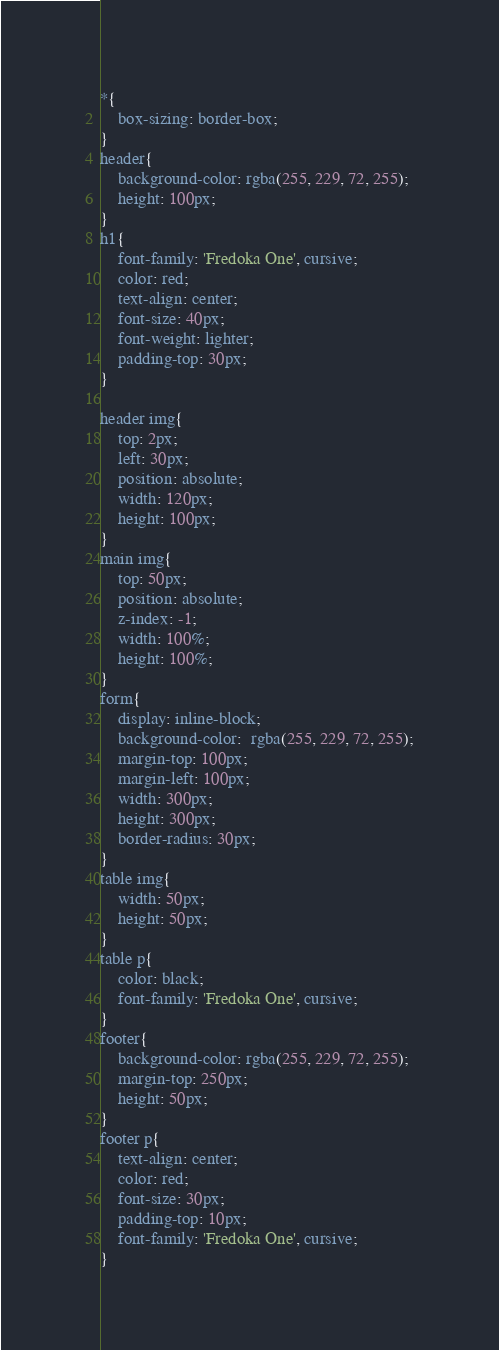Convert code to text. <code><loc_0><loc_0><loc_500><loc_500><_CSS_>*{
    box-sizing: border-box;
}
header{
    background-color: rgba(255, 229, 72, 255);
    height: 100px;
}
h1{
    font-family: 'Fredoka One', cursive;
    color: red;
    text-align: center;
    font-size: 40px;
    font-weight: lighter;
    padding-top: 30px;
}

header img{
    top: 2px;
    left: 30px;
    position: absolute;
    width: 120px;
    height: 100px;
}
main img{
    top: 50px;
    position: absolute;
    z-index: -1;
    width: 100%;
    height: 100%;
}
form{
    display: inline-block;
    background-color:  rgba(255, 229, 72, 255);
    margin-top: 100px;
    margin-left: 100px;
    width: 300px;
    height: 300px;
    border-radius: 30px;
}
table img{
    width: 50px;
    height: 50px;
}
table p{
    color: black;
    font-family: 'Fredoka One', cursive;
}
footer{
    background-color: rgba(255, 229, 72, 255);
    margin-top: 250px;
    height: 50px;
}
footer p{
    text-align: center;
    color: red;
    font-size: 30px;
    padding-top: 10px;
    font-family: 'Fredoka One', cursive;
}</code> 